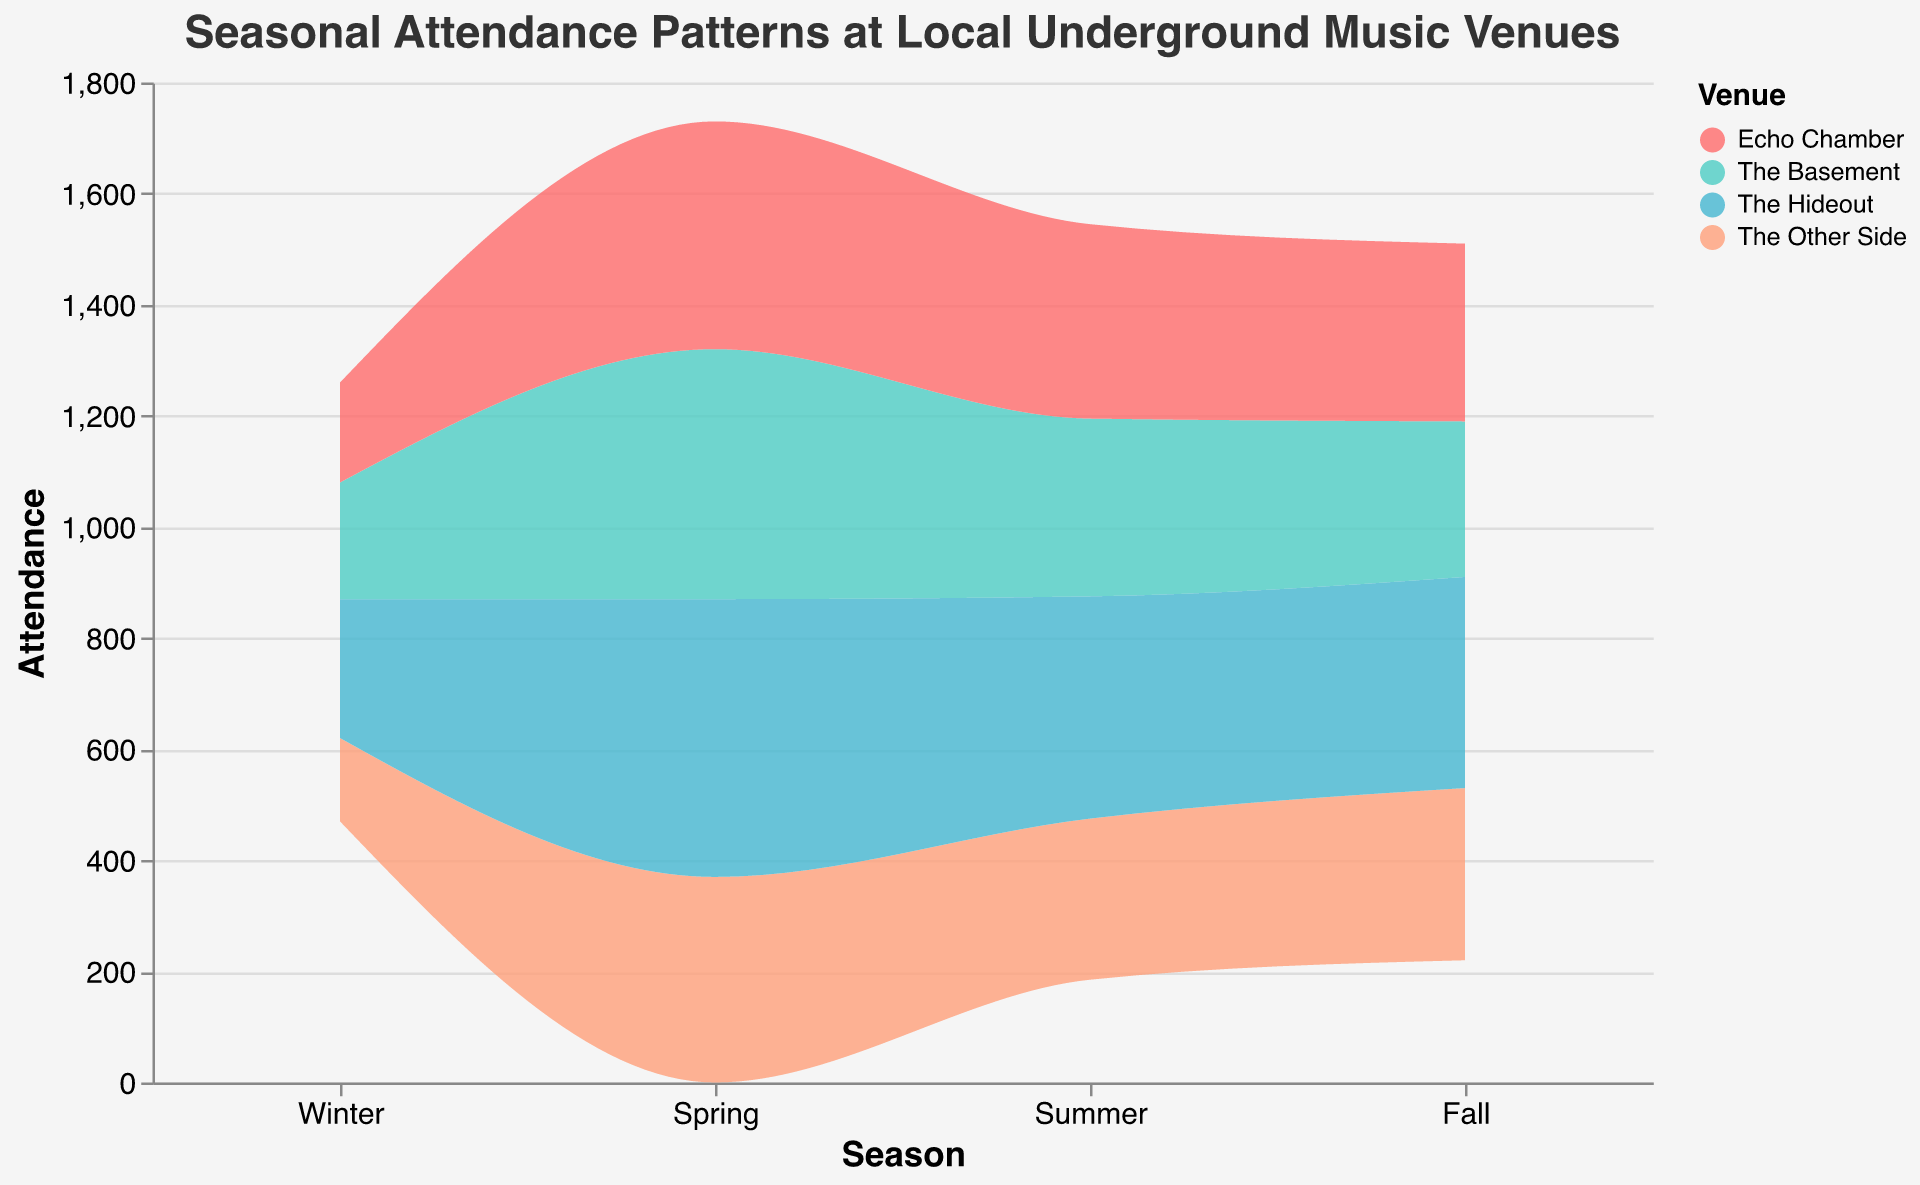What is the title of the figure? The title is placed at the top of the figure and provides a summary of its focus. In this case, the title is "Seasonal Attendance Patterns at Local Underground Music Venues."
Answer: Seasonal Attendance Patterns at Local Underground Music Venues How does attendance at The Hideout change across seasons? The plot shows an area for each venue with changing heights along the x-axis (seasons) representing attendance. Looking at the area corresponding to The Hideout, the attendance starts at 250 in Winter, rises to 500 in Spring, then drops to 400 in Summer, and finally decreases slightly to 380 in Fall.
Answer: 250 -> 500 -> 400 -> 380 Which venue has the highest attendance in the Spring? To find the highest attendance for each season, look for the topmost area for Spring. In Spring, The Hideout reaches an attendance of 500, which is the highest among all venues.
Answer: The Hideout What is the total attendance across all venues in Summer? To find the total attendance for Summer, sum the attendance for each venue in that season. For Summer: The Basement (320) + The Other Side (290) + Echo Chamber (350) + The Hideout (400) = 1360.
Answer: 1360 In which season is the overall attendance across all venues the lowest? Examine the thickness of the combined areas for each season to find where it is the thinnest. Winter's combined attendance seems the lowest: The Basement (210) + The Other Side (150) + Echo Chamber (180) + The Hideout (250) = 790. This is lower compared to other seasons.
Answer: Winter How does the attendance at Echo Chamber compare between Winter and Summer? Compare the heights of the area corresponding to Echo Chamber for Winter and Summer. Winter has an attendance of 180, while Summer is higher at 350.
Answer: Lower in Winter, higher in Summer Which two venues have the closest attendance figures in Fall? By looking at the top of each segment in Fall, Echo Chamber (320) and The Other Side (310) are closest in attendance. The difference is only 10.
Answer: Echo Chamber and The Other Side What is the average attendance at The Basement across all seasons? To find the average, sum the attendance of The Basement for all seasons and divide by the number of seasons. (210 + 450 + 320 + 280) / 4 = 1260 / 4 = 315.
Answer: 315 